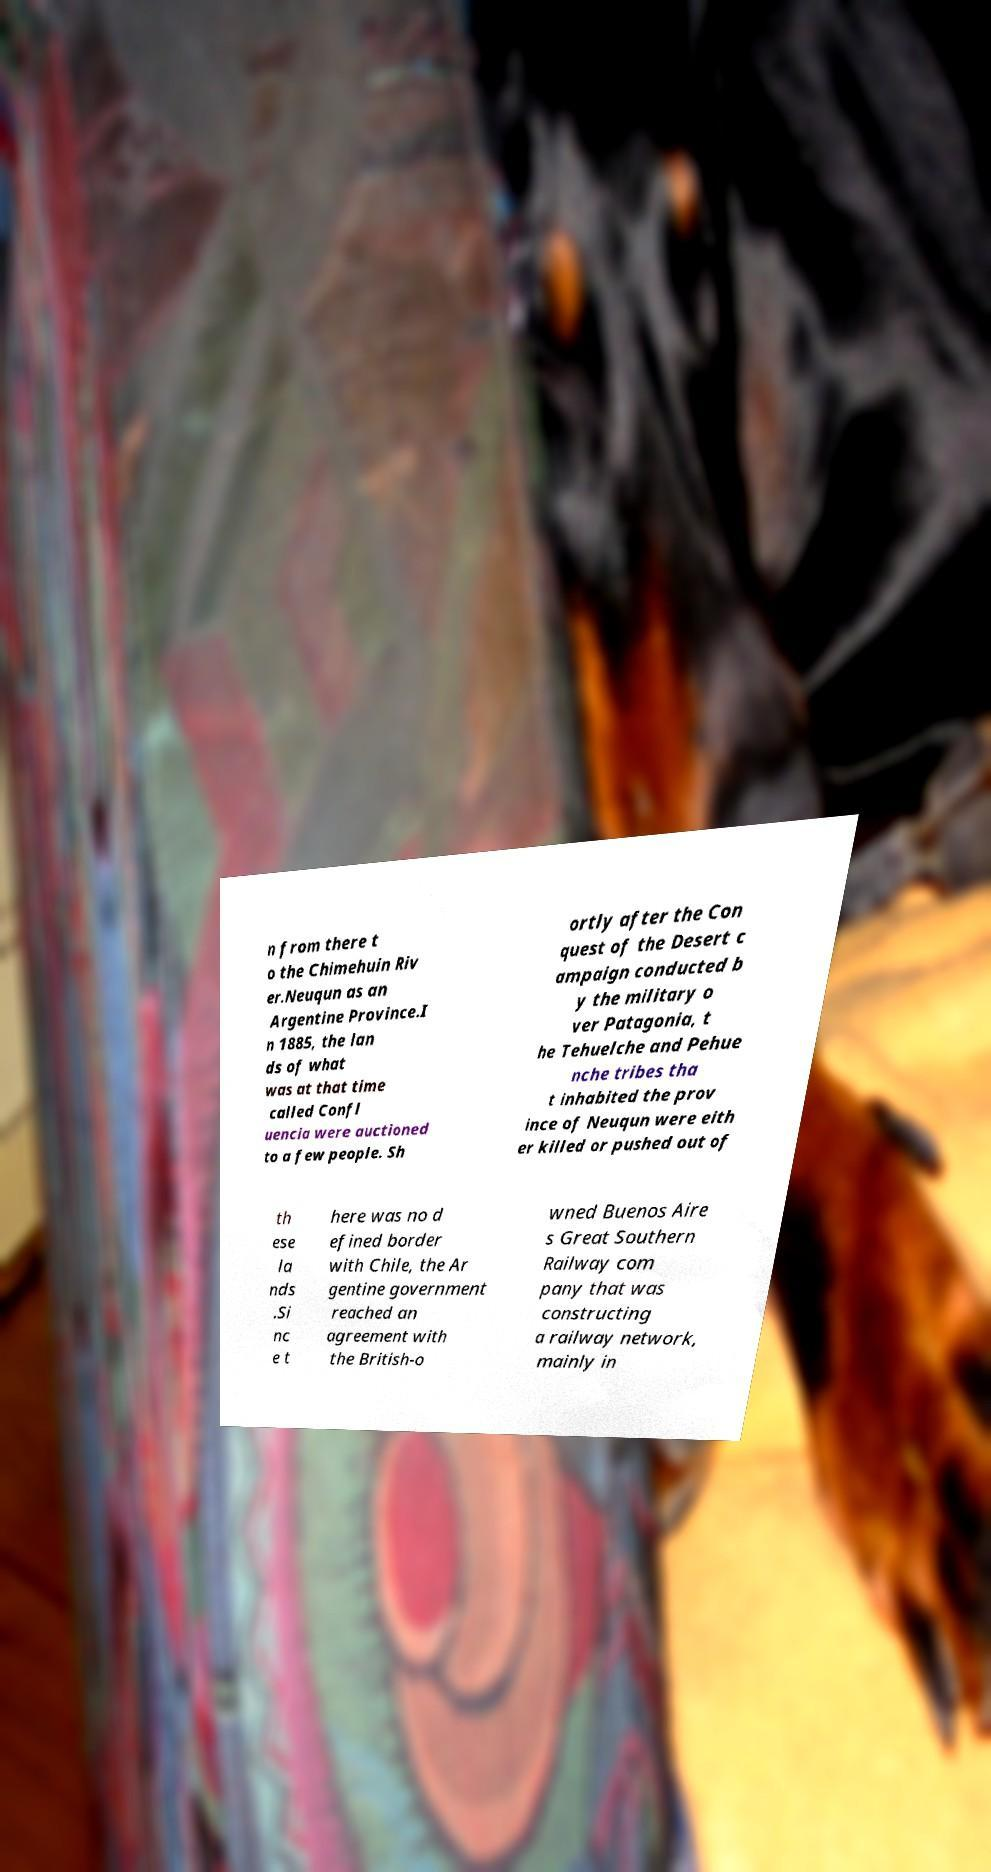What messages or text are displayed in this image? I need them in a readable, typed format. n from there t o the Chimehuin Riv er.Neuqun as an Argentine Province.I n 1885, the lan ds of what was at that time called Confl uencia were auctioned to a few people. Sh ortly after the Con quest of the Desert c ampaign conducted b y the military o ver Patagonia, t he Tehuelche and Pehue nche tribes tha t inhabited the prov ince of Neuqun were eith er killed or pushed out of th ese la nds .Si nc e t here was no d efined border with Chile, the Ar gentine government reached an agreement with the British-o wned Buenos Aire s Great Southern Railway com pany that was constructing a railway network, mainly in 